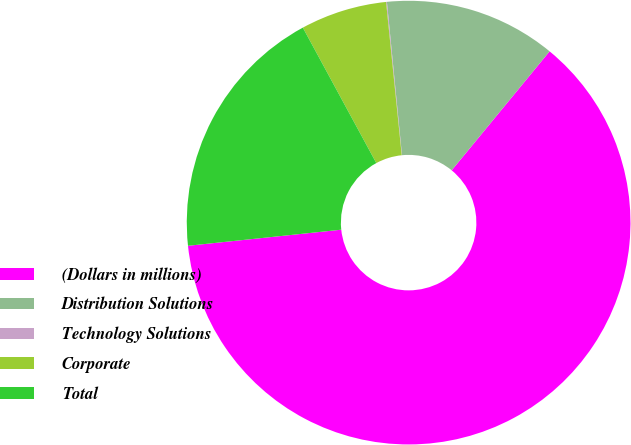Convert chart. <chart><loc_0><loc_0><loc_500><loc_500><pie_chart><fcel>(Dollars in millions)<fcel>Distribution Solutions<fcel>Technology Solutions<fcel>Corporate<fcel>Total<nl><fcel>62.37%<fcel>12.52%<fcel>0.06%<fcel>6.29%<fcel>18.75%<nl></chart> 